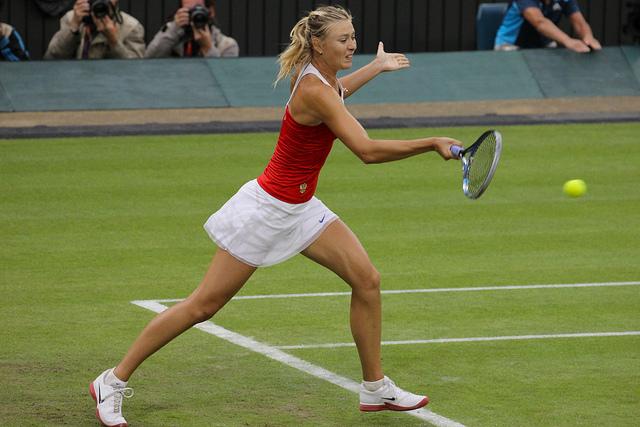Which game are they playing?
Be succinct. Tennis. What color hat is this person wearing?
Short answer required. None. How many camera's can you see?
Answer briefly. 2. Is this singles or doubles tennis?
Write a very short answer. Singles. What brand of shoes is the girl wearing?
Give a very brief answer. Nike. Does this lady have a braid in her hair?
Keep it brief. No. 